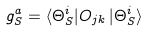<formula> <loc_0><loc_0><loc_500><loc_500>g _ { S } ^ { a } = \langle \Theta _ { S } ^ { i } | O _ { j k } \, | \Theta _ { S } ^ { i } \rangle</formula> 